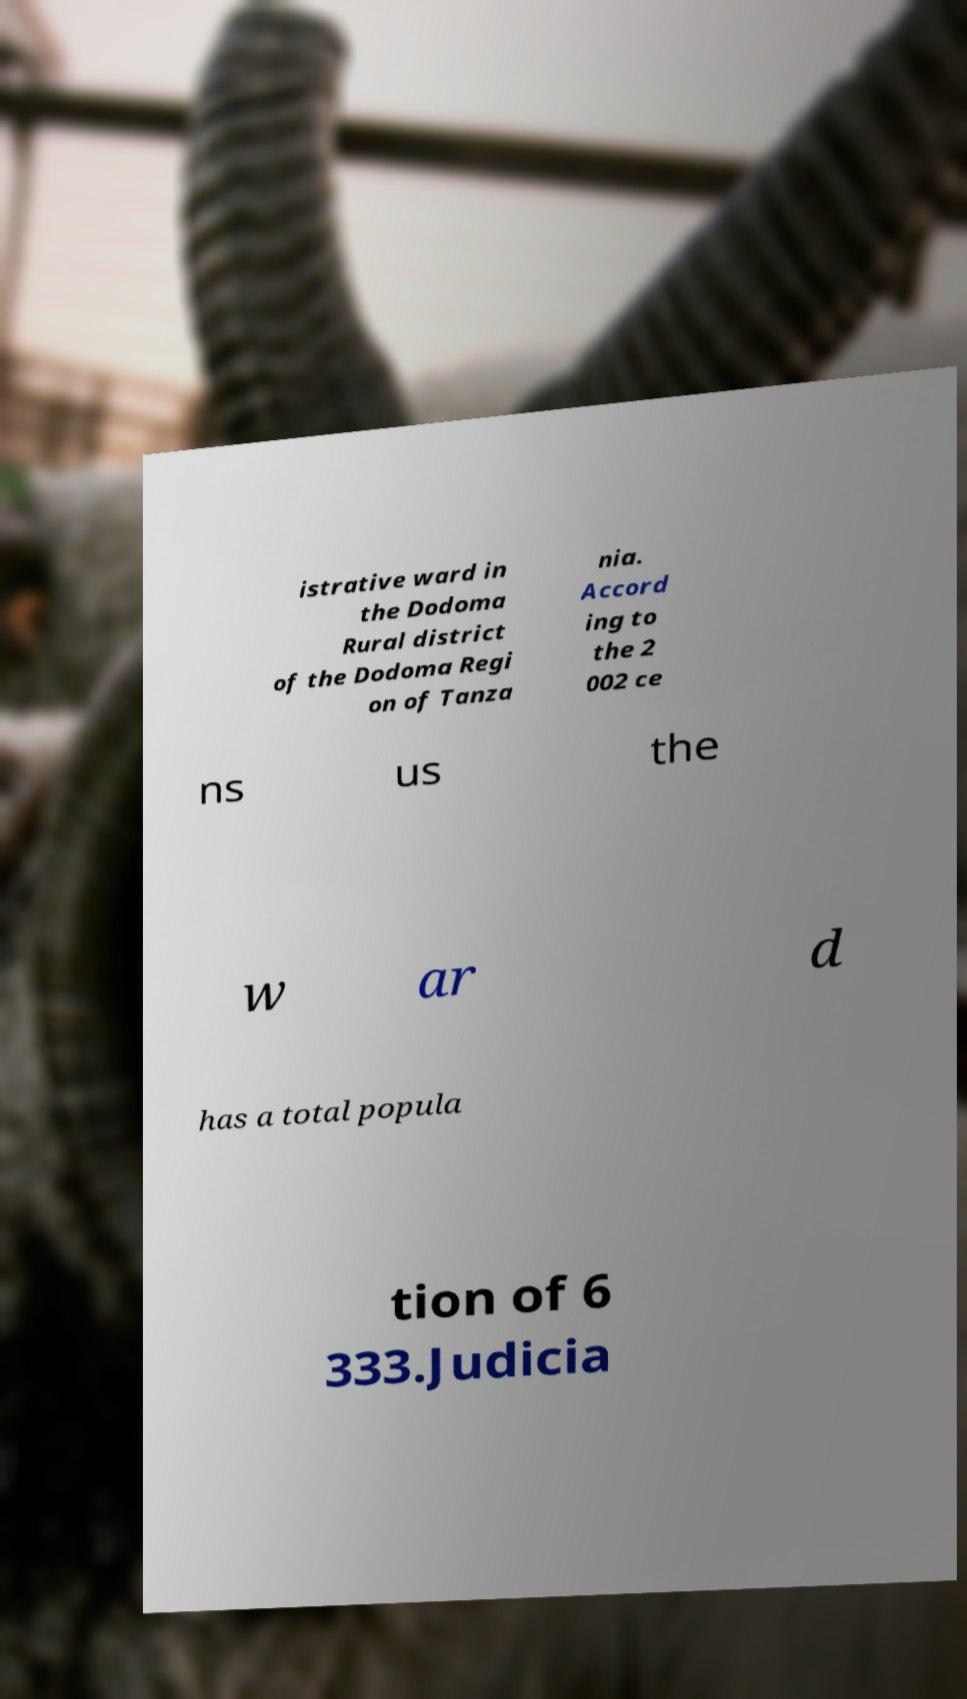What messages or text are displayed in this image? I need them in a readable, typed format. istrative ward in the Dodoma Rural district of the Dodoma Regi on of Tanza nia. Accord ing to the 2 002 ce ns us the w ar d has a total popula tion of 6 333.Judicia 